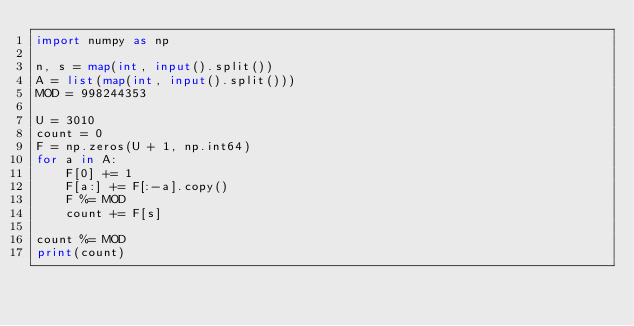Convert code to text. <code><loc_0><loc_0><loc_500><loc_500><_Python_>import numpy as np

n, s = map(int, input().split())
A = list(map(int, input().split()))
MOD = 998244353

U = 3010
count = 0
F = np.zeros(U + 1, np.int64)
for a in A:
    F[0] += 1
    F[a:] += F[:-a].copy()
    F %= MOD
    count += F[s]

count %= MOD
print(count)</code> 